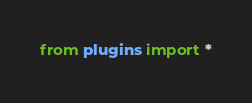<code> <loc_0><loc_0><loc_500><loc_500><_Python_>from plugins import *
</code> 